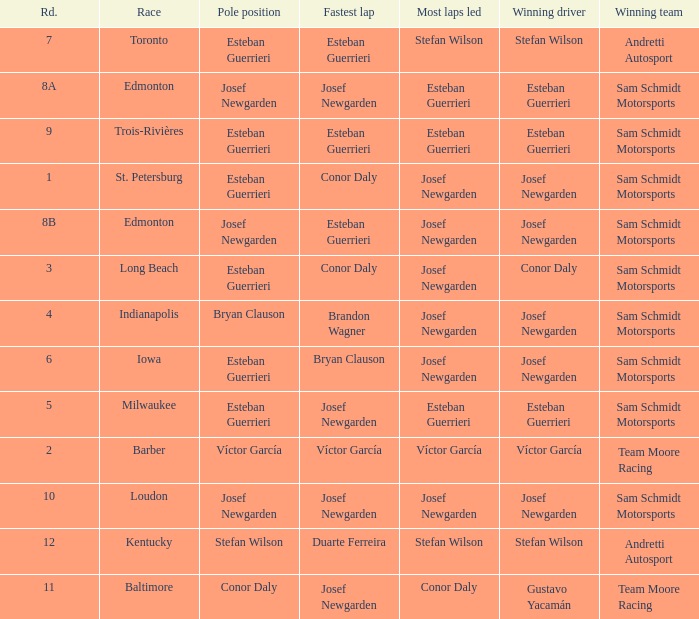Who had the fastest lap(s) when josef newgarden led the most laps at edmonton? Esteban Guerrieri. I'm looking to parse the entire table for insights. Could you assist me with that? {'header': ['Rd.', 'Race', 'Pole position', 'Fastest lap', 'Most laps led', 'Winning driver', 'Winning team'], 'rows': [['7', 'Toronto', 'Esteban Guerrieri', 'Esteban Guerrieri', 'Stefan Wilson', 'Stefan Wilson', 'Andretti Autosport'], ['8A', 'Edmonton', 'Josef Newgarden', 'Josef Newgarden', 'Esteban Guerrieri', 'Esteban Guerrieri', 'Sam Schmidt Motorsports'], ['9', 'Trois-Rivières', 'Esteban Guerrieri', 'Esteban Guerrieri', 'Esteban Guerrieri', 'Esteban Guerrieri', 'Sam Schmidt Motorsports'], ['1', 'St. Petersburg', 'Esteban Guerrieri', 'Conor Daly', 'Josef Newgarden', 'Josef Newgarden', 'Sam Schmidt Motorsports'], ['8B', 'Edmonton', 'Josef Newgarden', 'Esteban Guerrieri', 'Josef Newgarden', 'Josef Newgarden', 'Sam Schmidt Motorsports'], ['3', 'Long Beach', 'Esteban Guerrieri', 'Conor Daly', 'Josef Newgarden', 'Conor Daly', 'Sam Schmidt Motorsports'], ['4', 'Indianapolis', 'Bryan Clauson', 'Brandon Wagner', 'Josef Newgarden', 'Josef Newgarden', 'Sam Schmidt Motorsports'], ['6', 'Iowa', 'Esteban Guerrieri', 'Bryan Clauson', 'Josef Newgarden', 'Josef Newgarden', 'Sam Schmidt Motorsports'], ['5', 'Milwaukee', 'Esteban Guerrieri', 'Josef Newgarden', 'Esteban Guerrieri', 'Esteban Guerrieri', 'Sam Schmidt Motorsports'], ['2', 'Barber', 'Víctor García', 'Víctor García', 'Víctor García', 'Víctor García', 'Team Moore Racing'], ['10', 'Loudon', 'Josef Newgarden', 'Josef Newgarden', 'Josef Newgarden', 'Josef Newgarden', 'Sam Schmidt Motorsports'], ['12', 'Kentucky', 'Stefan Wilson', 'Duarte Ferreira', 'Stefan Wilson', 'Stefan Wilson', 'Andretti Autosport'], ['11', 'Baltimore', 'Conor Daly', 'Josef Newgarden', 'Conor Daly', 'Gustavo Yacamán', 'Team Moore Racing']]} 